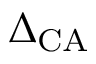<formula> <loc_0><loc_0><loc_500><loc_500>\Delta _ { C A }</formula> 